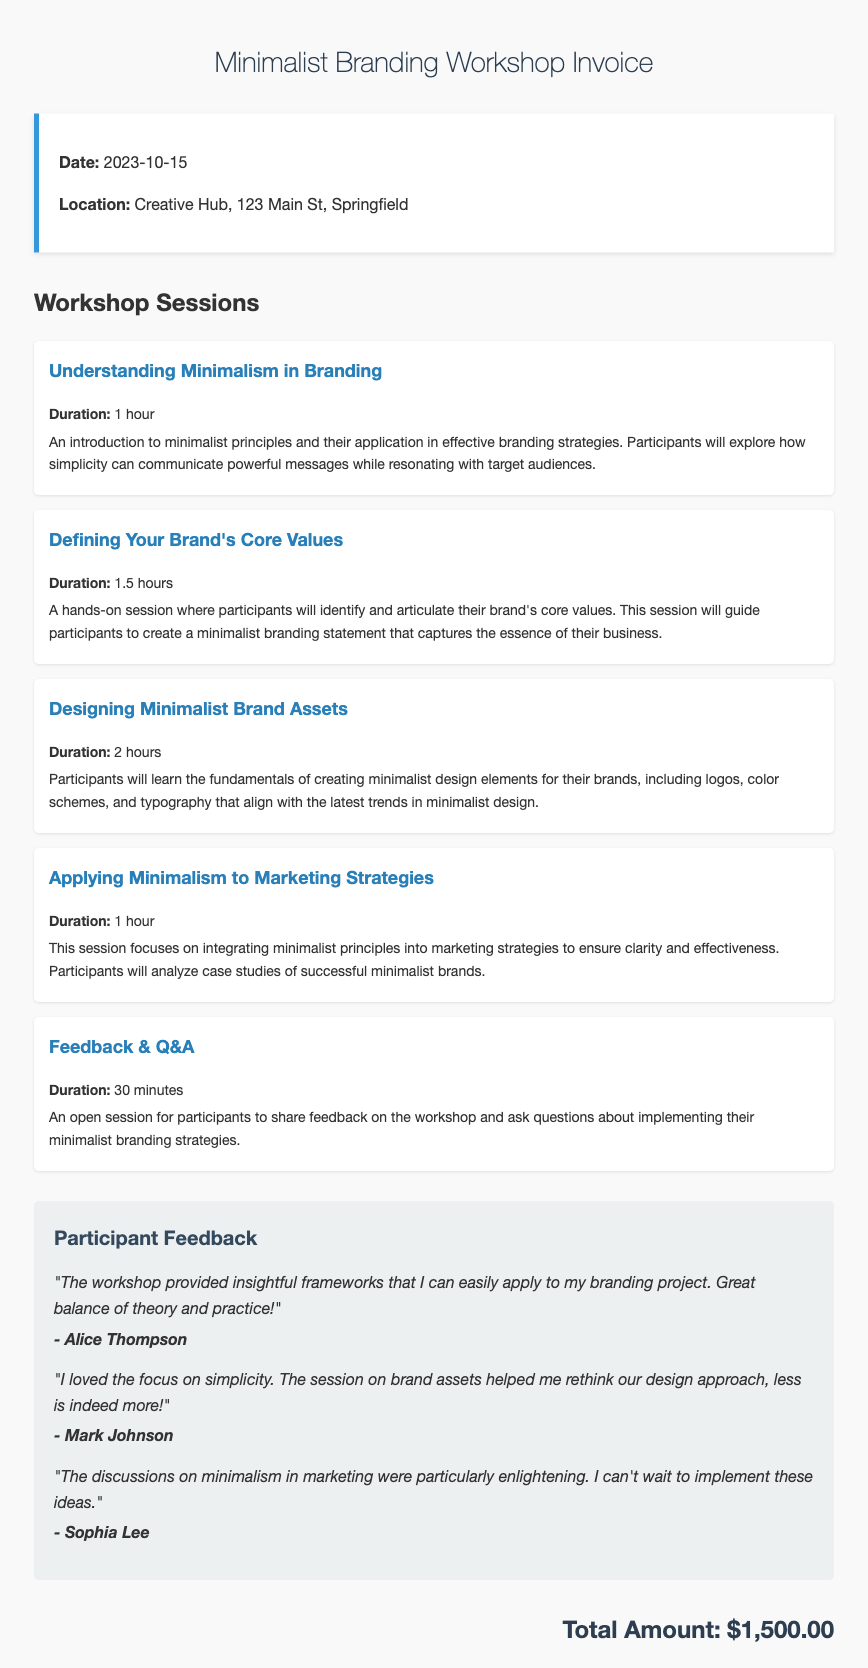What is the date of the workshop? The date of the workshop is specified in the document.
Answer: 2023-10-15 Where is the workshop located? The location of the workshop is mentioned in the document.
Answer: Creative Hub, 123 Main St, Springfield How long is the session on "Designing Minimalist Brand Assets"? The duration of this session is provided in the workshop details.
Answer: 2 hours What is the total amount for the invoice? The total amount at the end of the document specifies the cost of the workshop.
Answer: $1,500.00 Who provided the feedback stating, "The workshop provided insightful frameworks that I can easily apply to my branding project"? The name of the participant who provided this feedback is given in the feedback section.
Answer: Alice Thompson Which session focuses on integrating minimalist principles into marketing strategies? The specific session title is provided in the workshop sessions.
Answer: Applying Minimalism to Marketing Strategies What is the primary theme of the feedback from participants? The feedback summarizes the general sentiments of participants regarding the workshop's focus and effectiveness.
Answer: Simplicity What is the duration of the "Feedback & Q&A" session? The length of this session is mentioned in the workshop description.
Answer: 30 minutes 